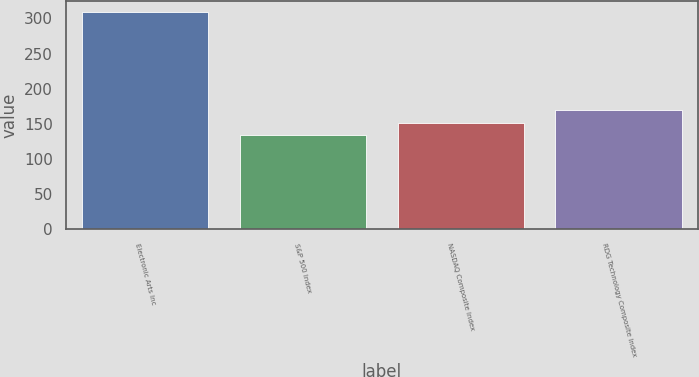Convert chart to OTSL. <chart><loc_0><loc_0><loc_500><loc_500><bar_chart><fcel>Electronic Arts Inc<fcel>S&P 500 Index<fcel>NASDAQ Composite Index<fcel>RDG Technology Composite Index<nl><fcel>309<fcel>134<fcel>151.5<fcel>169<nl></chart> 